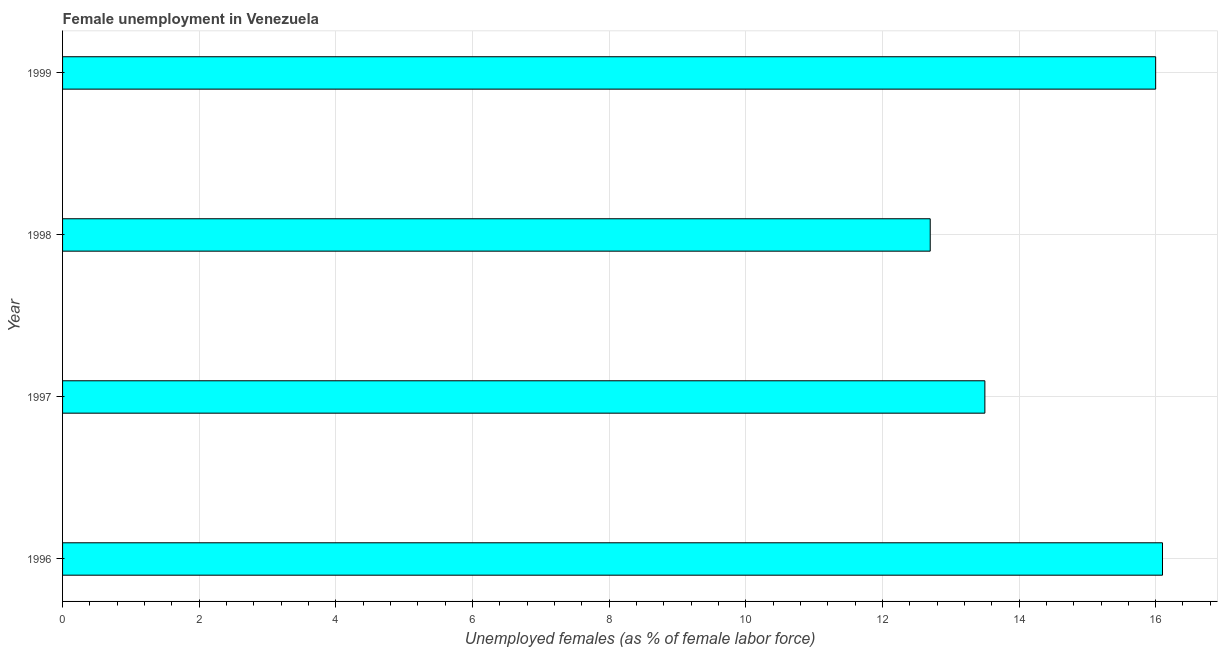What is the title of the graph?
Keep it short and to the point. Female unemployment in Venezuela. What is the label or title of the X-axis?
Your response must be concise. Unemployed females (as % of female labor force). Across all years, what is the maximum unemployed females population?
Ensure brevity in your answer.  16.1. Across all years, what is the minimum unemployed females population?
Offer a very short reply. 12.7. In which year was the unemployed females population maximum?
Keep it short and to the point. 1996. What is the sum of the unemployed females population?
Give a very brief answer. 58.3. What is the average unemployed females population per year?
Provide a short and direct response. 14.57. What is the median unemployed females population?
Offer a very short reply. 14.75. Do a majority of the years between 1998 and 1997 (inclusive) have unemployed females population greater than 14.8 %?
Keep it short and to the point. No. What is the ratio of the unemployed females population in 1996 to that in 1998?
Keep it short and to the point. 1.27. What is the difference between the highest and the second highest unemployed females population?
Keep it short and to the point. 0.1. Is the sum of the unemployed females population in 1997 and 1998 greater than the maximum unemployed females population across all years?
Give a very brief answer. Yes. What is the difference between the highest and the lowest unemployed females population?
Provide a succinct answer. 3.4. In how many years, is the unemployed females population greater than the average unemployed females population taken over all years?
Your answer should be compact. 2. Are all the bars in the graph horizontal?
Keep it short and to the point. Yes. How many years are there in the graph?
Your response must be concise. 4. Are the values on the major ticks of X-axis written in scientific E-notation?
Offer a very short reply. No. What is the Unemployed females (as % of female labor force) in 1996?
Your response must be concise. 16.1. What is the Unemployed females (as % of female labor force) of 1998?
Ensure brevity in your answer.  12.7. What is the Unemployed females (as % of female labor force) in 1999?
Provide a short and direct response. 16. What is the difference between the Unemployed females (as % of female labor force) in 1996 and 1998?
Offer a terse response. 3.4. What is the difference between the Unemployed females (as % of female labor force) in 1997 and 1998?
Ensure brevity in your answer.  0.8. What is the difference between the Unemployed females (as % of female labor force) in 1998 and 1999?
Your answer should be very brief. -3.3. What is the ratio of the Unemployed females (as % of female labor force) in 1996 to that in 1997?
Offer a very short reply. 1.19. What is the ratio of the Unemployed females (as % of female labor force) in 1996 to that in 1998?
Offer a very short reply. 1.27. What is the ratio of the Unemployed females (as % of female labor force) in 1997 to that in 1998?
Provide a succinct answer. 1.06. What is the ratio of the Unemployed females (as % of female labor force) in 1997 to that in 1999?
Offer a very short reply. 0.84. What is the ratio of the Unemployed females (as % of female labor force) in 1998 to that in 1999?
Offer a terse response. 0.79. 